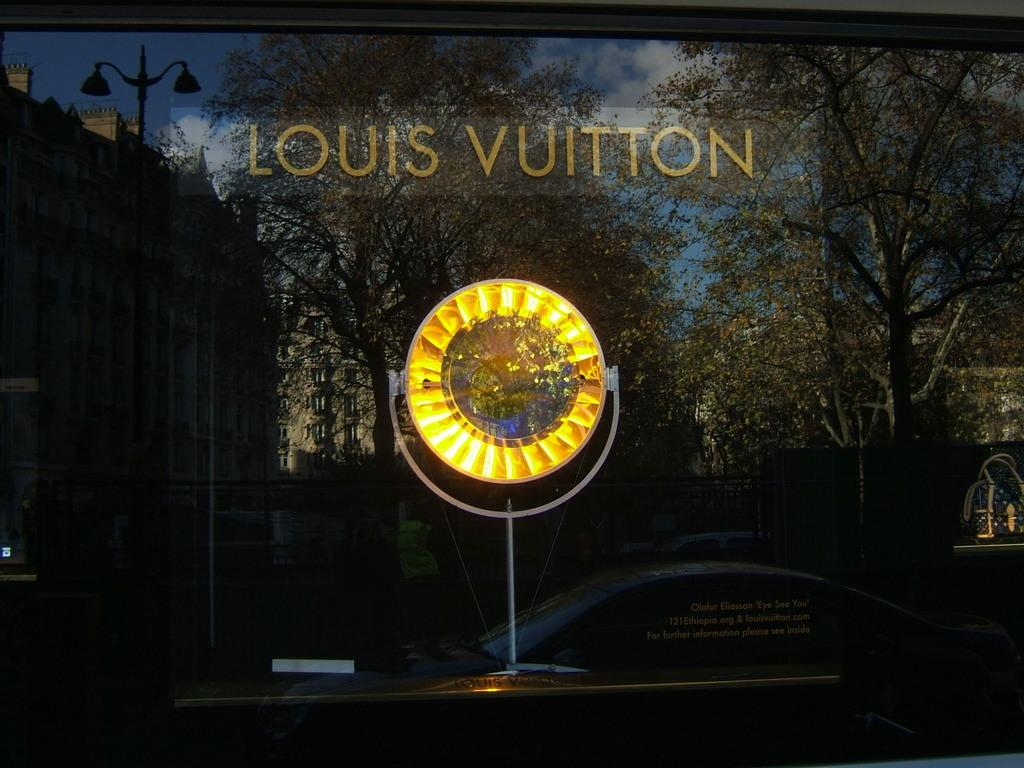What is the main object with text in the image? There is an object with text in the image, but we cannot determine its exact nature from the given facts. What can be seen in the background of the image? In the background of the image, there are vehicles, trees, a person, buildings, a pole, and the sky. Can you describe the setting of the image based on the background? The background suggests an urban or suburban setting, with buildings, vehicles, and a person present. What type of garden can be seen in the image? There is no garden present in the image. What kind of boundary is visible in the image? There is no boundary visible in the image. 